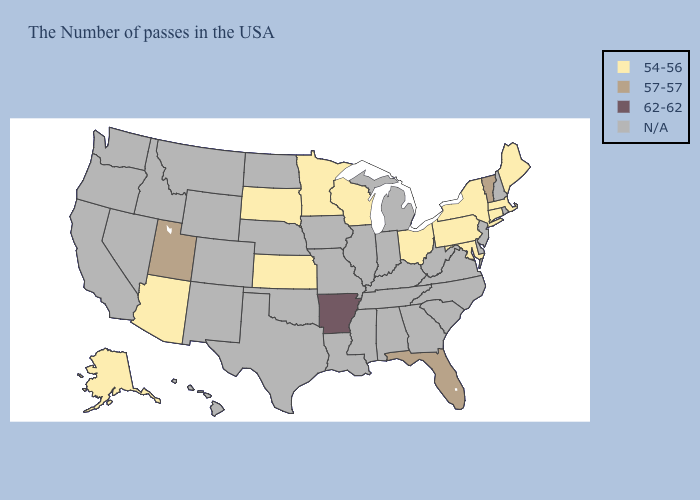Name the states that have a value in the range N/A?
Keep it brief. Rhode Island, New Hampshire, New Jersey, Delaware, Virginia, North Carolina, South Carolina, West Virginia, Georgia, Michigan, Kentucky, Indiana, Alabama, Tennessee, Illinois, Mississippi, Louisiana, Missouri, Iowa, Nebraska, Oklahoma, Texas, North Dakota, Wyoming, Colorado, New Mexico, Montana, Idaho, Nevada, California, Washington, Oregon, Hawaii. Name the states that have a value in the range 62-62?
Quick response, please. Arkansas. Which states have the lowest value in the USA?
Quick response, please. Maine, Massachusetts, Connecticut, New York, Maryland, Pennsylvania, Ohio, Wisconsin, Minnesota, Kansas, South Dakota, Arizona, Alaska. Which states have the highest value in the USA?
Answer briefly. Arkansas. Name the states that have a value in the range 62-62?
Give a very brief answer. Arkansas. What is the highest value in states that border Nebraska?
Be succinct. 54-56. What is the value of Alaska?
Write a very short answer. 54-56. Name the states that have a value in the range N/A?
Write a very short answer. Rhode Island, New Hampshire, New Jersey, Delaware, Virginia, North Carolina, South Carolina, West Virginia, Georgia, Michigan, Kentucky, Indiana, Alabama, Tennessee, Illinois, Mississippi, Louisiana, Missouri, Iowa, Nebraska, Oklahoma, Texas, North Dakota, Wyoming, Colorado, New Mexico, Montana, Idaho, Nevada, California, Washington, Oregon, Hawaii. Does Maryland have the highest value in the South?
Write a very short answer. No. 